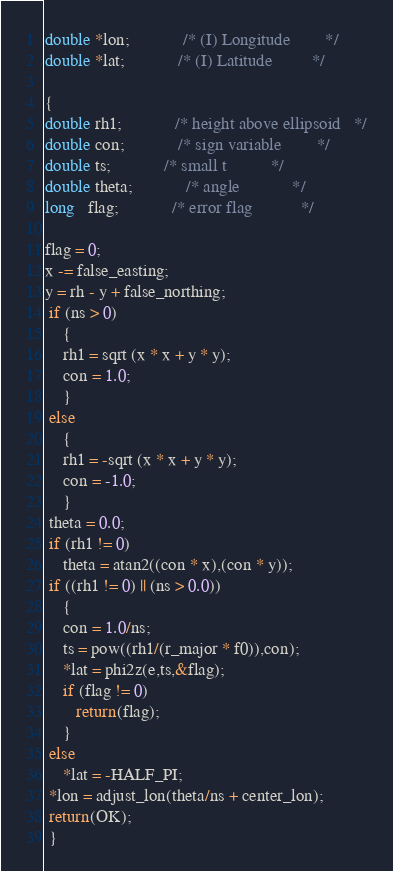Convert code to text. <code><loc_0><loc_0><loc_500><loc_500><_C_>double *lon;			/* (I) Longitude 		*/
double *lat;			/* (I) Latitude 		*/

{
double rh1;			/* height above ellipsoid	*/
double con;			/* sign variable		*/
double ts;			/* small t			*/
double theta;			/* angle			*/
long   flag;			/* error flag			*/

flag = 0;
x -= false_easting;
y = rh - y + false_northing;
 if (ns > 0)
    {
    rh1 = sqrt (x * x + y * y);
    con = 1.0;
    }
 else
    {
    rh1 = -sqrt (x * x + y * y);
    con = -1.0;
    }
 theta = 0.0;
 if (rh1 != 0)
    theta = atan2((con * x),(con * y));
 if ((rh1 != 0) || (ns > 0.0))
    {
    con = 1.0/ns;
    ts = pow((rh1/(r_major * f0)),con);
    *lat = phi2z(e,ts,&flag);
    if (flag != 0)
       return(flag);
    }
 else
    *lat = -HALF_PI;
 *lon = adjust_lon(theta/ns + center_lon);
 return(OK);
 }
</code> 